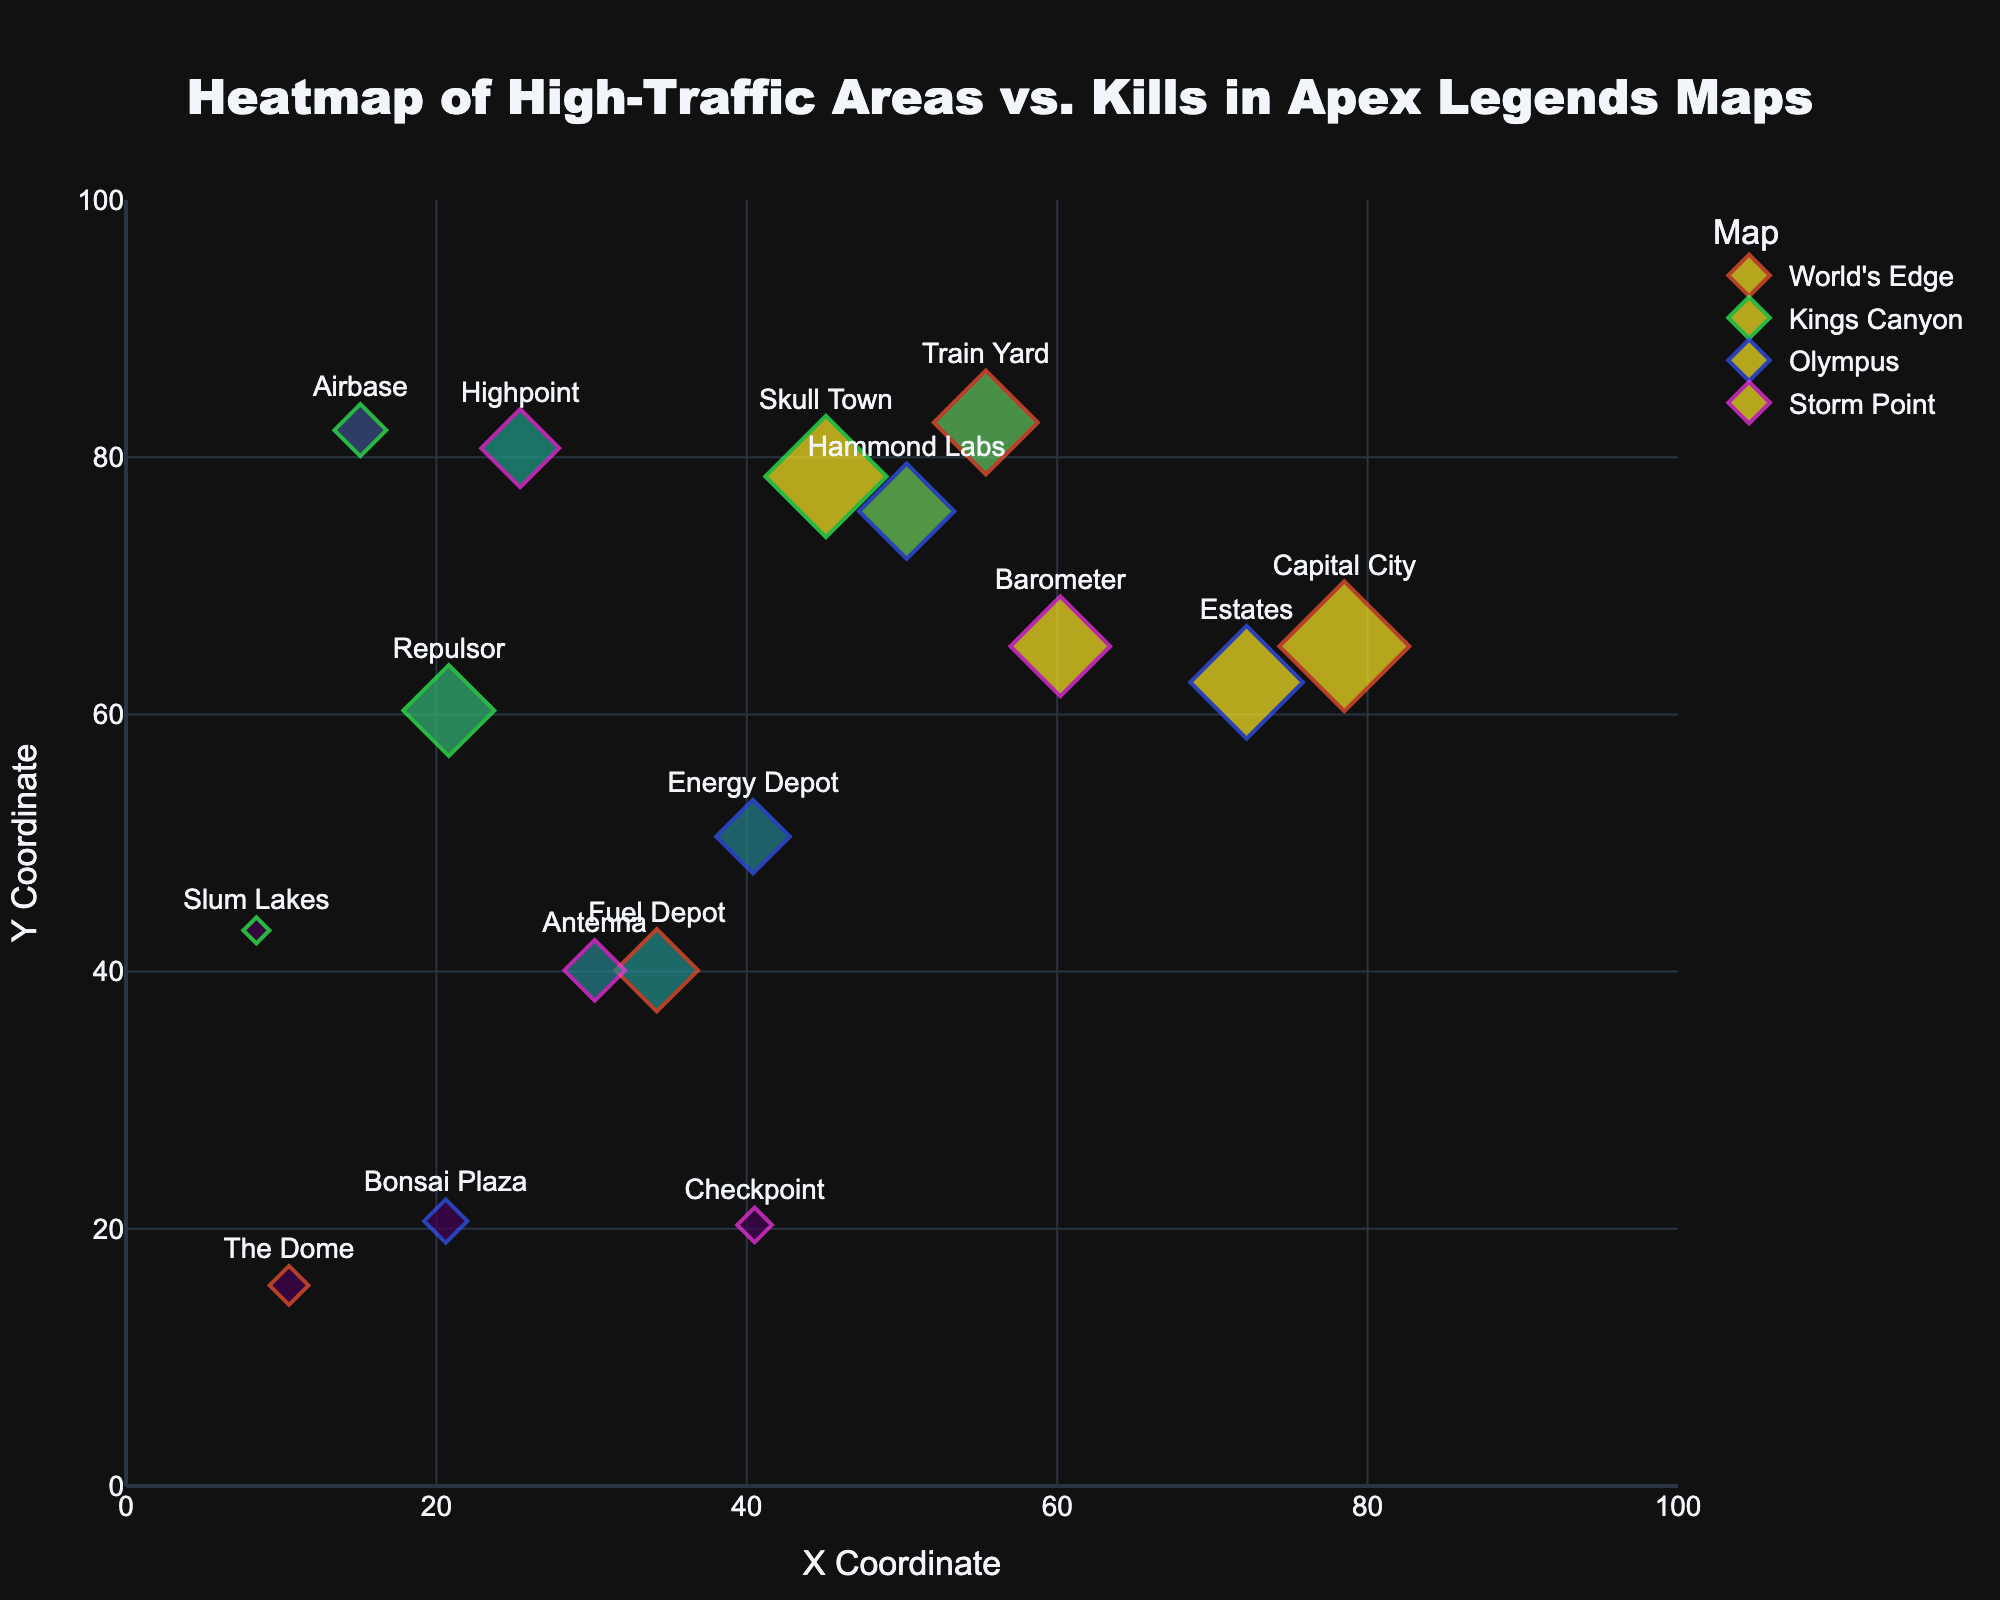What's the title of the figure? The title is located at the top of the figure, centered. It gives an overview of what the figure is representing.
Answer: Heatmap of High-Traffic Areas vs. Kills in Apex Legends Maps What are the X and Y coordinates for the location "Capital City"? You can find the coordinates by looking at the label "Capital City" and checking the position on the plot. The coordinates are given in the dataset.
Answer: 78.5, 65.3 Which map has the location with the highest number of kills? To find this, check the size of the markers, as larger markers represent more kills. The largest marker corresponds to Capital City in World's Edge.
Answer: World's Edge How many locations have a heatmap score greater than 70? Identify the markers with color intensities in the highest range, corresponding to higher heatmap scores. Then count these markers.
Answer: 6 Which location in Olympus has the least number of kills? Find all locations within Olympus by checking the legend and markers. Then, find the one with the smallest size. Bonsai Plaza has the fewest kills.
Answer: Bonsai Plaza Which location in King's Canyon has the highest heatmap score? Look for locations in King's Canyon by examining the markers specific to this map (green lines). The one with the highest heatmap score will have the most intense color, which is Skull Town.
Answer: Skull Town Compare the heatmap scores of "Antenna" and "Checkpoint" in Storm Point; which one is higher? These locations are distinguished by their position and labels in Storm Point's section on the plot. Compare their colors to see which is more intense.
Answer: Antenna Is the number of kills at "Energy Depot" in Olympus closer to "Fuel Depot" in World's Edge or "Barometer" in Storm Point? Compare the marker sizes of Energy Depot, Fuel Depot, and Barometer to find which one is numerically closer. Energy Depot has 85 kills, closest to Barometer with 115 kills.
Answer: Barometer What is the average heatmap score of all locations in World's Edge? Sum the heatmap scores of all locations in World's Edge and divide by the number of locations (3 in this case). The scores are 90, 75, and 60. (90 + 75 + 60) / 3 = 75
Answer: 75 Which map has the overall highest average number of kills across all its locations? Calculate the average number of kills for each map and compare. For World's Edge: (150+120+95+45)/4 = 102.5; Kings Canyon: (140+105+60+30)/4 = 83.75; Olympus: (130+110+85+50)/4 = 93.75; Storm Point: (115+90+70+40)/4 = 78.75. World's Edge has the highest average.
Answer: World's Edge 